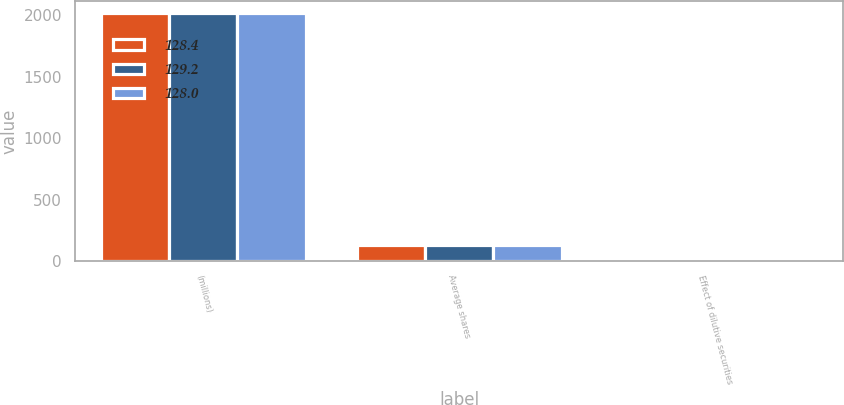Convert chart. <chart><loc_0><loc_0><loc_500><loc_500><stacked_bar_chart><ecel><fcel>(millions)<fcel>Average shares<fcel>Effect of dilutive securities<nl><fcel>128.4<fcel>2017<fcel>128.4<fcel>1.6<nl><fcel>129.2<fcel>2016<fcel>128<fcel>1.4<nl><fcel>128<fcel>2015<fcel>129.2<fcel>1.2<nl></chart> 